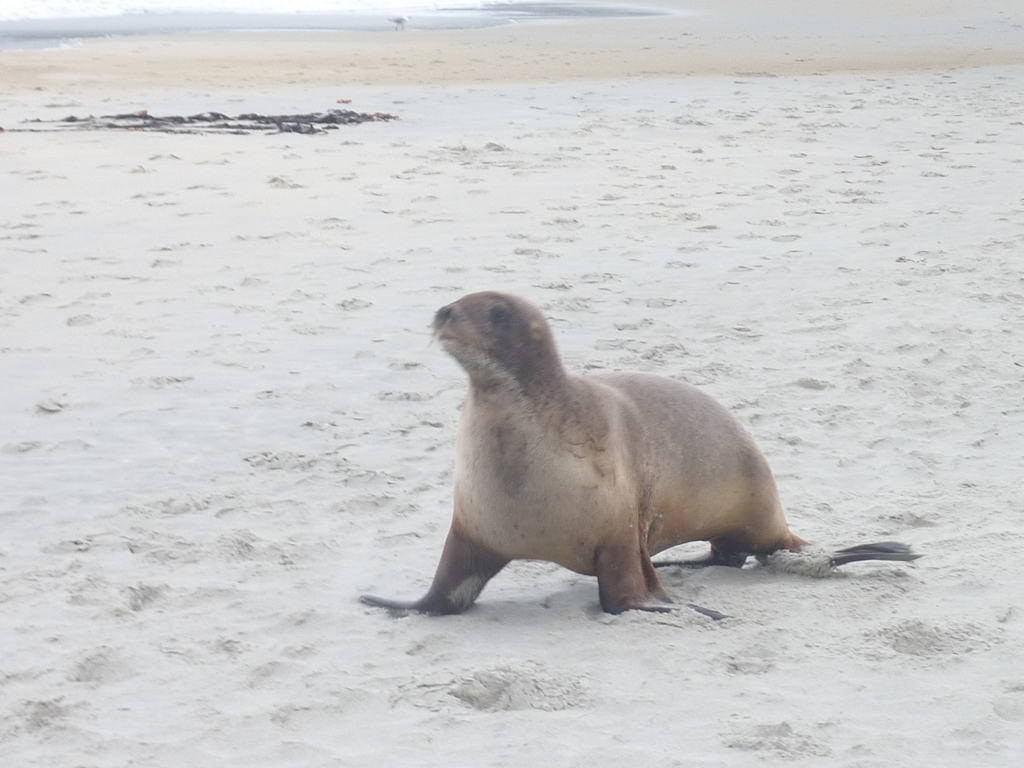Can you describe the environment in which the seal is found? The seal is on a sandy beach. It looks like a wide, open space with damp sand, suggesting a coastline. The overcast sky suggests it might be a cooler day. 